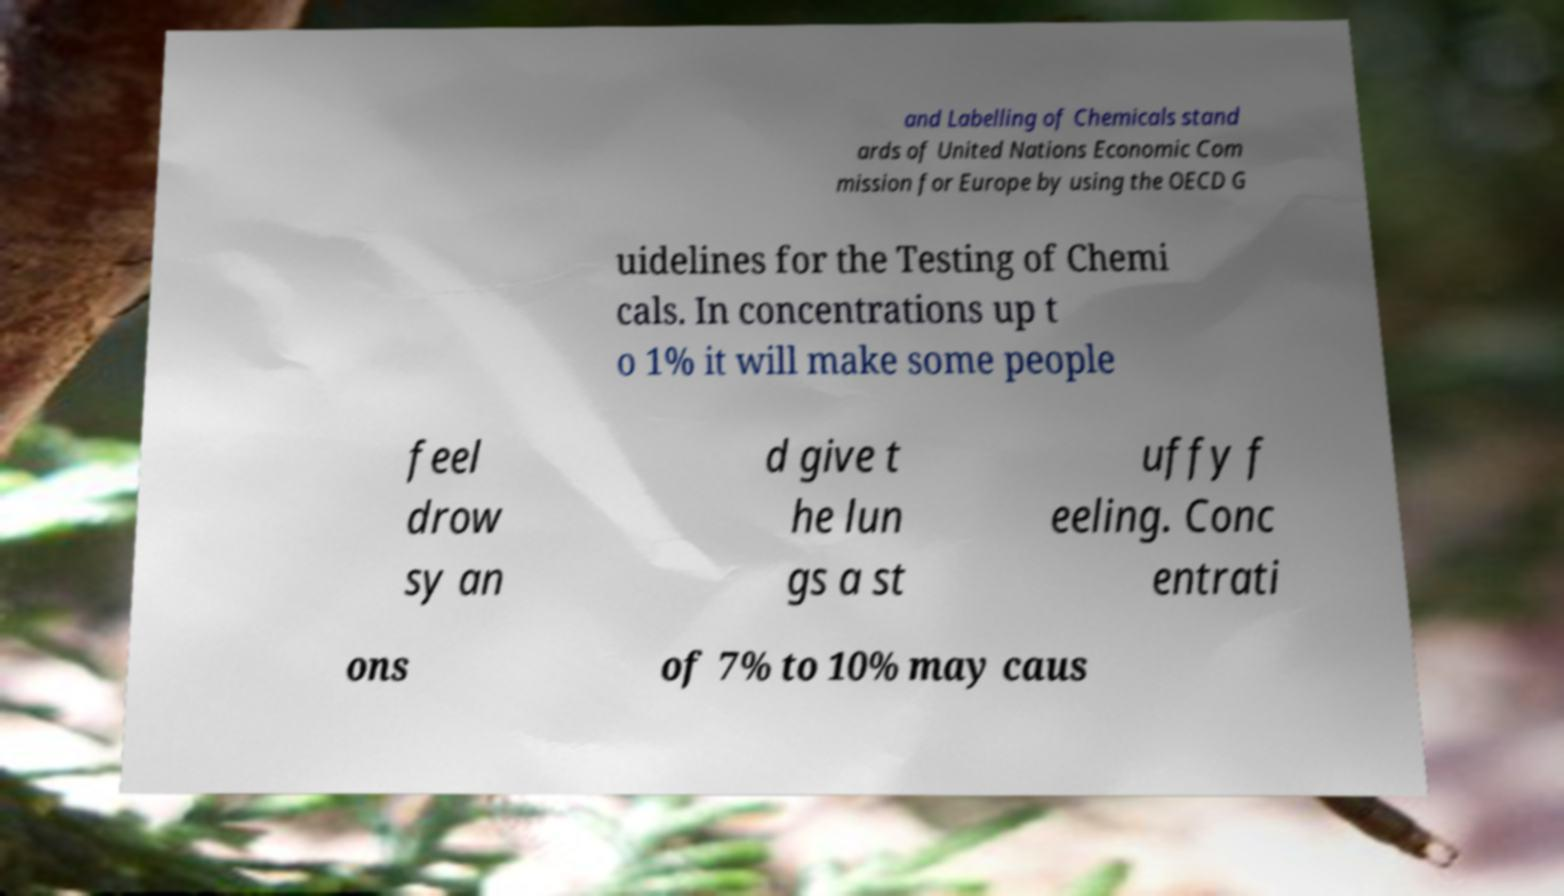There's text embedded in this image that I need extracted. Can you transcribe it verbatim? and Labelling of Chemicals stand ards of United Nations Economic Com mission for Europe by using the OECD G uidelines for the Testing of Chemi cals. In concentrations up t o 1% it will make some people feel drow sy an d give t he lun gs a st uffy f eeling. Conc entrati ons of 7% to 10% may caus 